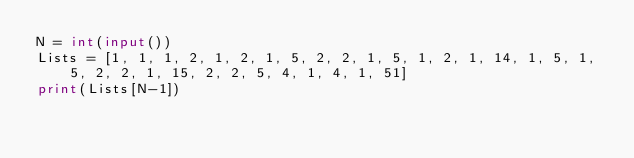Convert code to text. <code><loc_0><loc_0><loc_500><loc_500><_Python_>N = int(input())
Lists = [1, 1, 1, 2, 1, 2, 1, 5, 2, 2, 1, 5, 1, 2, 1, 14, 1, 5, 1, 5, 2, 2, 1, 15, 2, 2, 5, 4, 1, 4, 1, 51]
print(Lists[N-1])</code> 